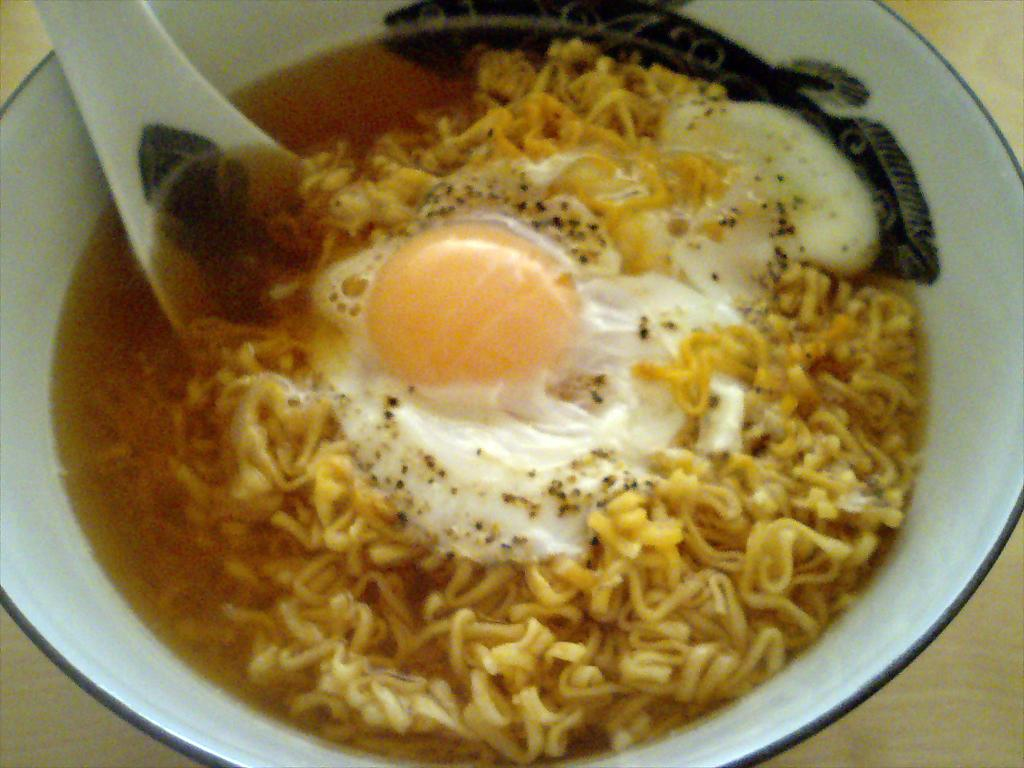What type of food is visible in the image? There are noodles in the image. What other item can be seen in the image? There is an egg in the image. What utensil is present in the image? There is a spoon in the image. What color is the bowl in the image? The bowl is white-colored. What type of surface is the bowl placed on? The bowl is on a wooden surface. What type of sea creature can be seen swimming in the image? There is no sea creature present in the image; it features noodles, an egg, a spoon, and a white bowl on a wooden surface. 